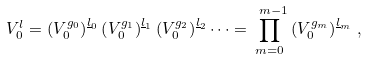Convert formula to latex. <formula><loc_0><loc_0><loc_500><loc_500>V ^ { l } _ { 0 } = \left ( V _ { 0 } ^ { g _ { 0 } } \right ) ^ { \underline { l } _ { 0 } } \left ( V _ { 0 } ^ { g _ { 1 } } \right ) ^ { \underline { l } _ { 1 } } \left ( V _ { 0 } ^ { g _ { 2 } } \right ) ^ { \underline { l } _ { 2 } } \cdots = \prod _ { m = 0 } ^ { \ m - 1 } \left ( V _ { 0 } ^ { g _ { m } } \right ) ^ { \underline { l } _ { m } } \, ,</formula> 